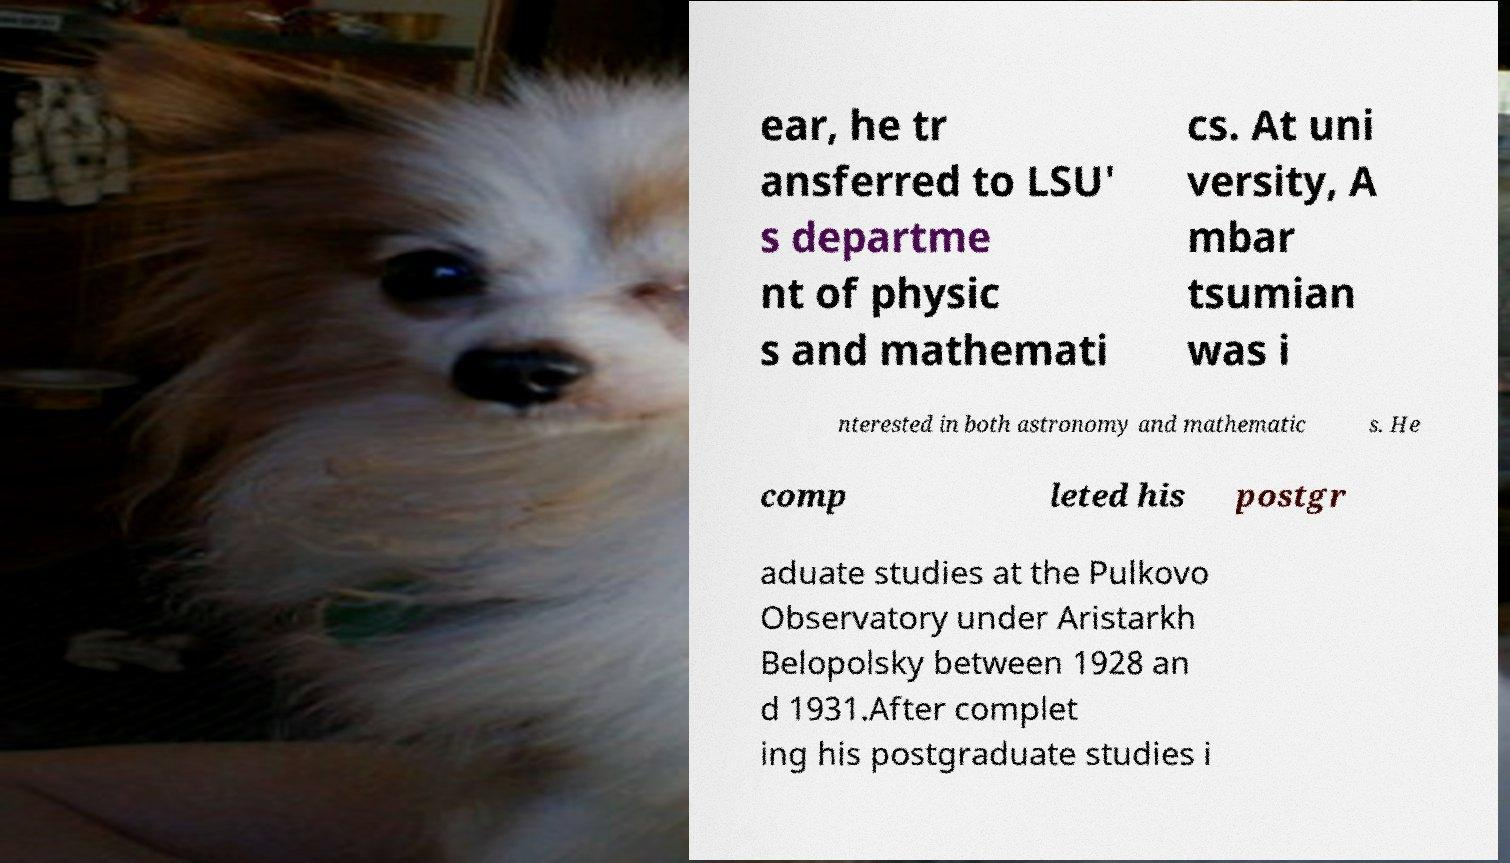Can you accurately transcribe the text from the provided image for me? ear, he tr ansferred to LSU' s departme nt of physic s and mathemati cs. At uni versity, A mbar tsumian was i nterested in both astronomy and mathematic s. He comp leted his postgr aduate studies at the Pulkovo Observatory under Aristarkh Belopolsky between 1928 an d 1931.After complet ing his postgraduate studies i 